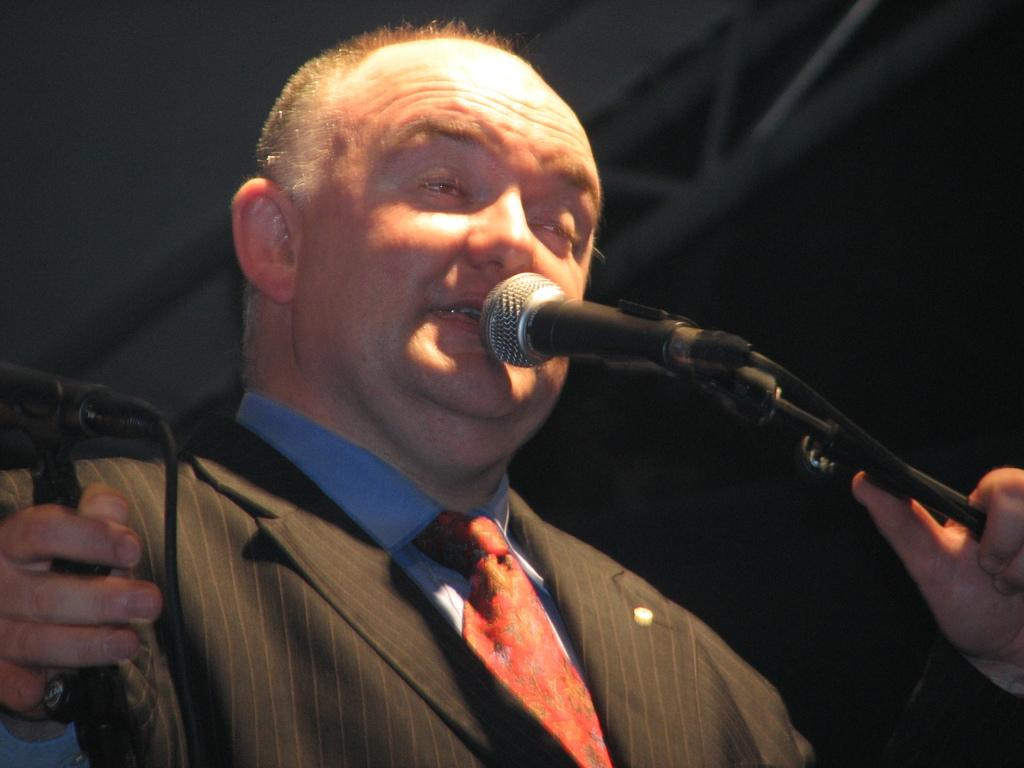What is the main subject of the image? There is a person in the image. What is the person wearing? The person is wearing a blazer. What is the person holding in the image? The person is holding a mic. How many clocks are visible on the person's blazer in the image? There are no clocks visible on the person's blazer in the image. What type of sign is the person holding in the image? The person is not holding a sign in the image; they are holding a mic. 